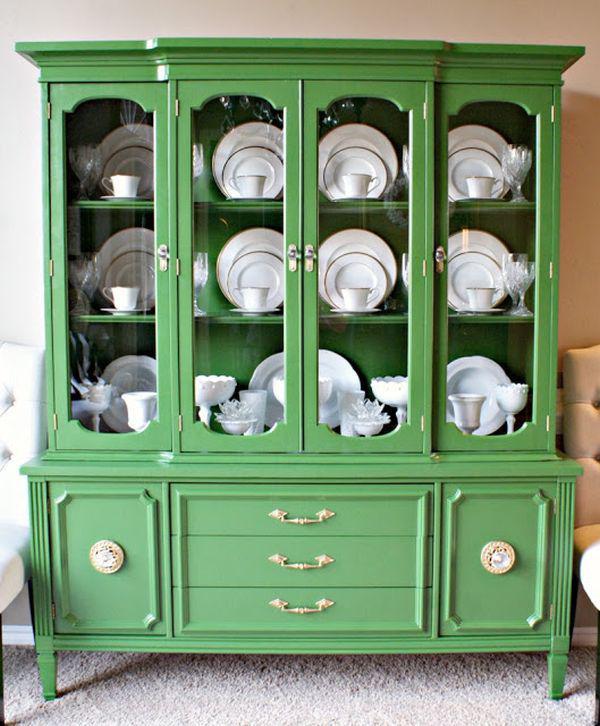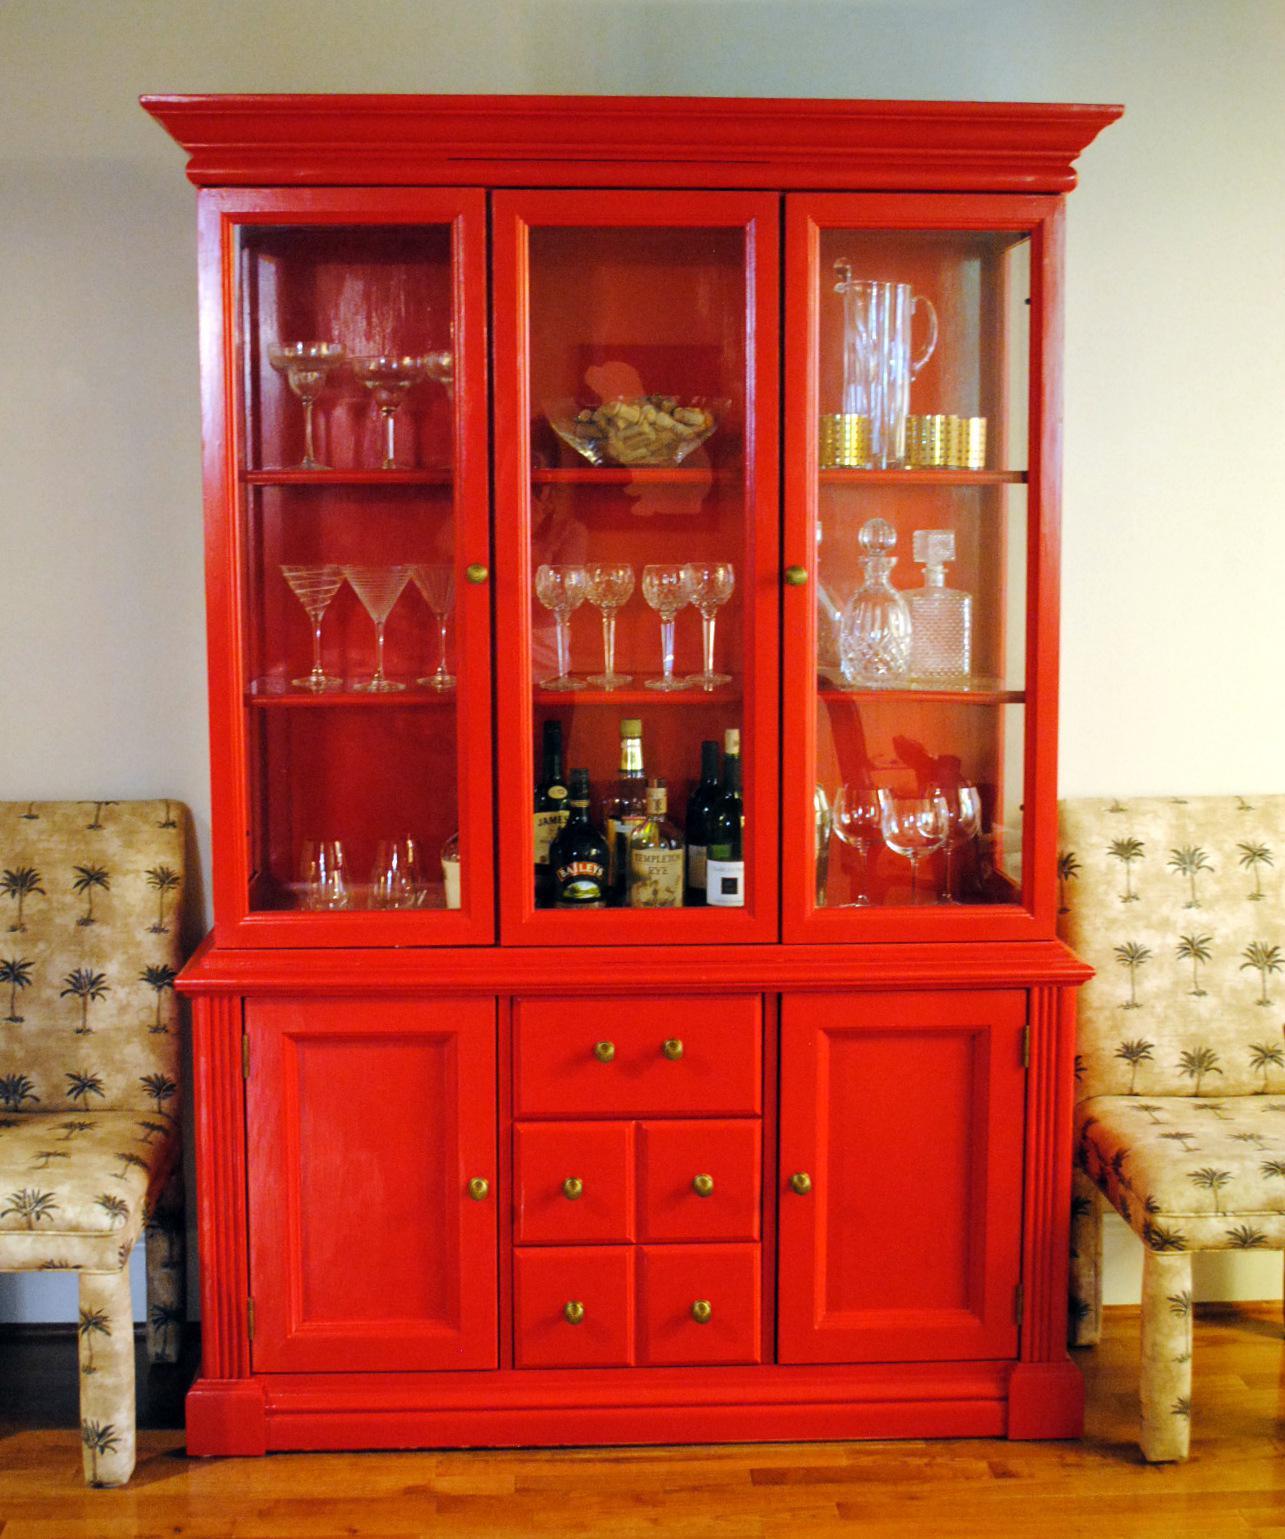The first image is the image on the left, the second image is the image on the right. For the images shown, is this caption "An image shows a brown cabinet with an arched top and open doors." true? Answer yes or no. No. The first image is the image on the left, the second image is the image on the right. Examine the images to the left and right. Is the description "One of the cabinets containing dishes is brown." accurate? Answer yes or no. No. 